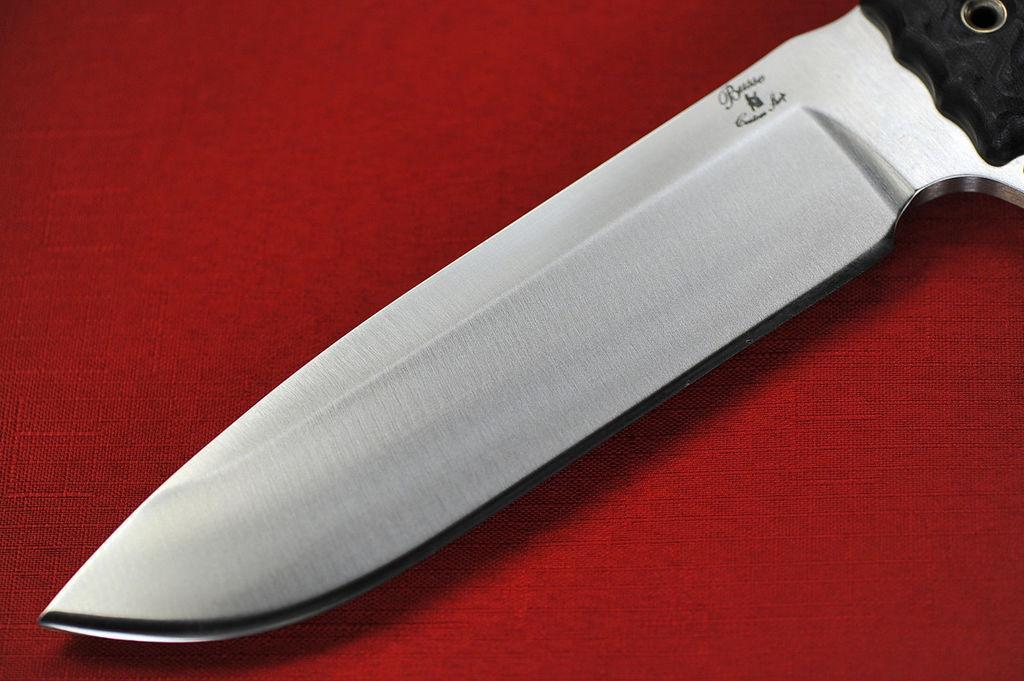Please provide a concise description of this image. In this image, we can see a knife and holder. On the knife, we can see some text and symbol. This knife is placed on the red surface. 